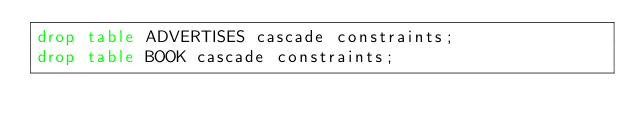<code> <loc_0><loc_0><loc_500><loc_500><_SQL_>drop table ADVERTISES cascade constraints;
drop table BOOK cascade constraints;</code> 